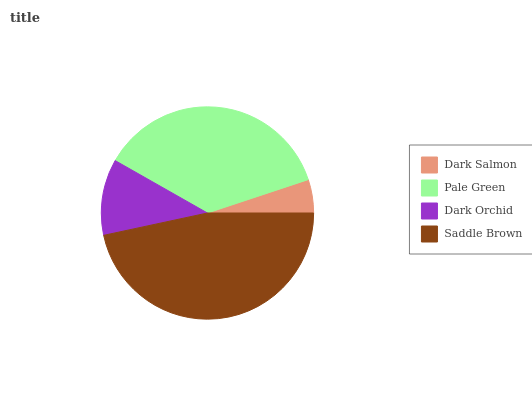Is Dark Salmon the minimum?
Answer yes or no. Yes. Is Saddle Brown the maximum?
Answer yes or no. Yes. Is Pale Green the minimum?
Answer yes or no. No. Is Pale Green the maximum?
Answer yes or no. No. Is Pale Green greater than Dark Salmon?
Answer yes or no. Yes. Is Dark Salmon less than Pale Green?
Answer yes or no. Yes. Is Dark Salmon greater than Pale Green?
Answer yes or no. No. Is Pale Green less than Dark Salmon?
Answer yes or no. No. Is Pale Green the high median?
Answer yes or no. Yes. Is Dark Orchid the low median?
Answer yes or no. Yes. Is Dark Salmon the high median?
Answer yes or no. No. Is Dark Salmon the low median?
Answer yes or no. No. 